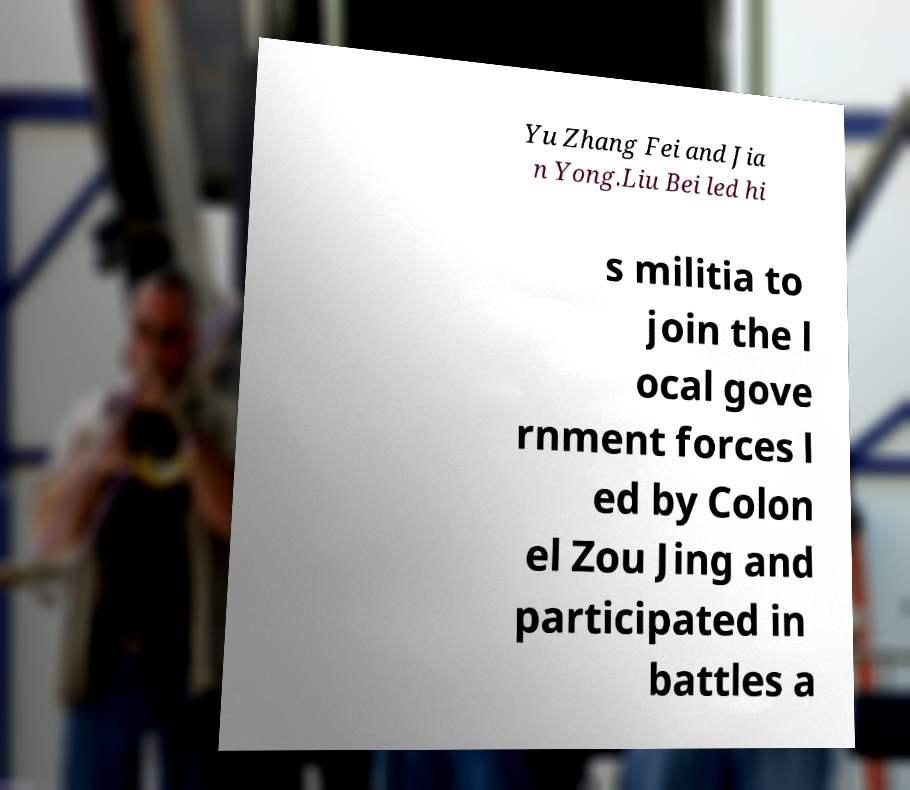Could you extract and type out the text from this image? Yu Zhang Fei and Jia n Yong.Liu Bei led hi s militia to join the l ocal gove rnment forces l ed by Colon el Zou Jing and participated in battles a 